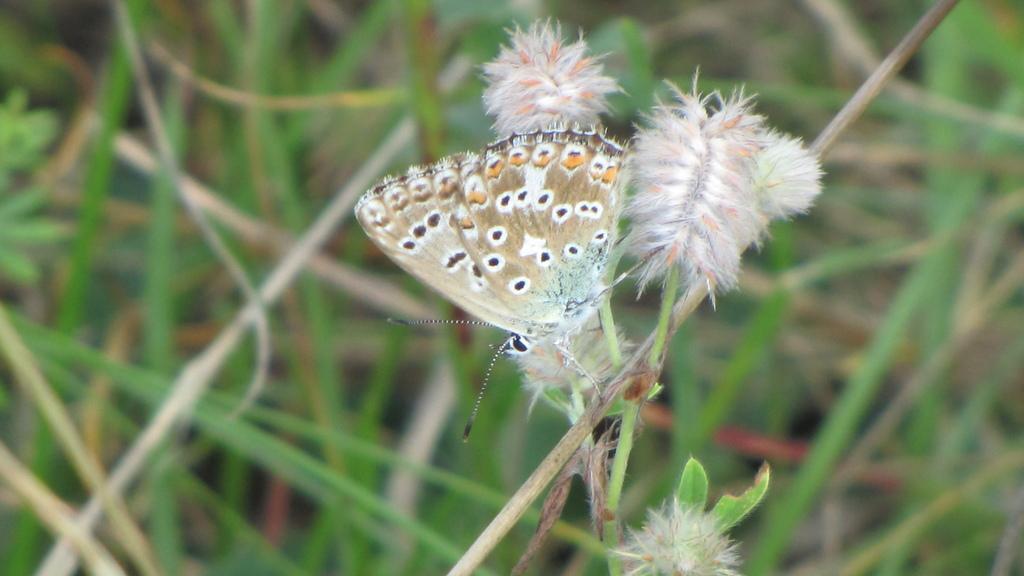Can you describe this image briefly? Here we can see a butterfly. Background it is blur. 